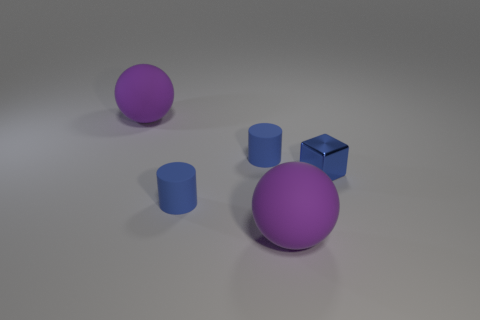Add 3 small blue cylinders. How many objects exist? 8 Subtract all cylinders. How many objects are left? 3 Add 1 large green matte spheres. How many large green matte spheres exist? 1 Subtract 0 purple cylinders. How many objects are left? 5 Subtract all purple things. Subtract all purple matte spheres. How many objects are left? 1 Add 3 large matte balls. How many large matte balls are left? 5 